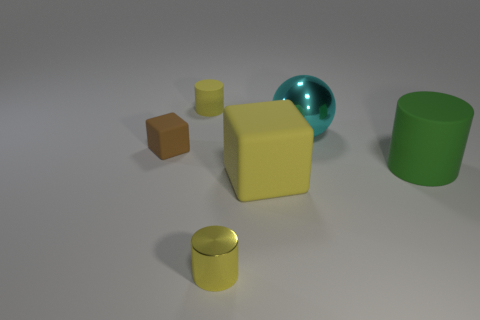How many things are both in front of the cyan metal sphere and on the left side of the large sphere?
Provide a short and direct response. 3. Are there any tiny brown blocks made of the same material as the large yellow object?
Ensure brevity in your answer.  Yes. There is a large cyan sphere that is behind the tiny cylinder that is in front of the big cylinder; what is it made of?
Your answer should be compact. Metal. Is the number of large green rubber cylinders that are in front of the yellow metal object the same as the number of yellow cubes behind the green thing?
Your answer should be compact. Yes. Does the yellow metallic thing have the same shape as the brown thing?
Your answer should be compact. No. There is a big thing that is on the left side of the big cylinder and behind the big yellow block; what material is it made of?
Offer a terse response. Metal. What number of other shiny things have the same shape as the green thing?
Offer a very short reply. 1. There is a metallic object behind the matte cylinder that is right of the metal object that is on the right side of the big block; what size is it?
Provide a succinct answer. Large. Is the number of small brown matte cubes left of the yellow rubber block greater than the number of small cyan shiny cylinders?
Your answer should be compact. Yes. Are there any big cyan matte cylinders?
Your answer should be compact. No. 